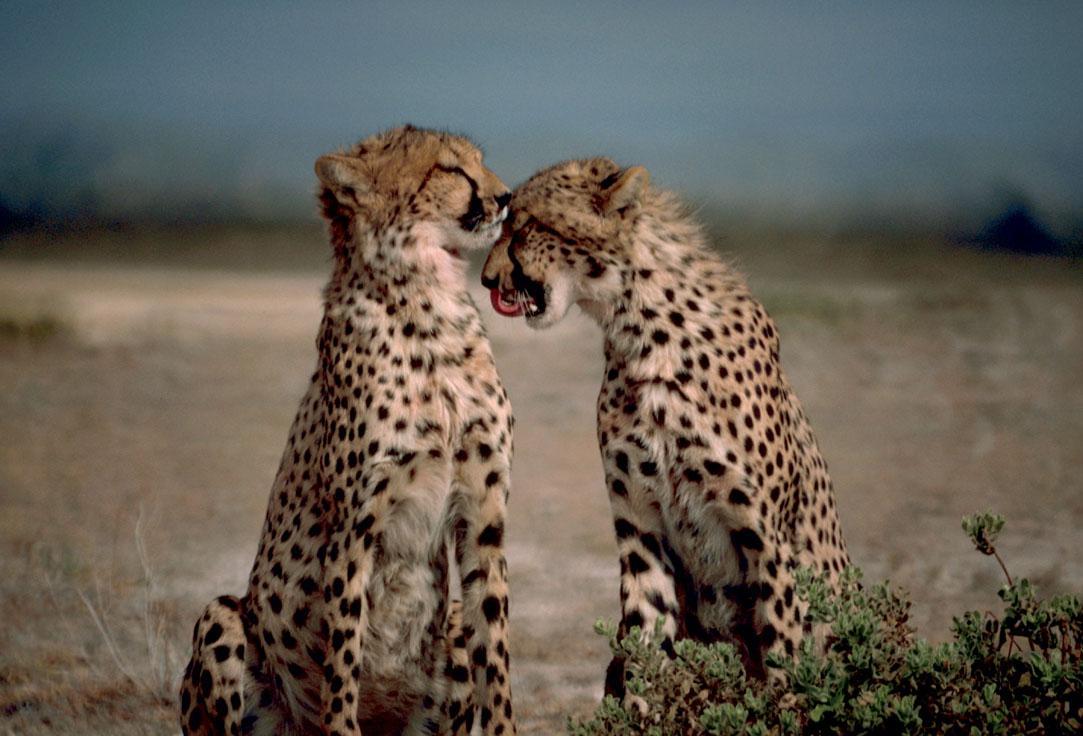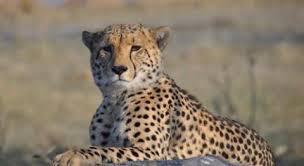The first image is the image on the left, the second image is the image on the right. Considering the images on both sides, is "One image has two Cheetahs with one licking the other." valid? Answer yes or no. Yes. The first image is the image on the left, the second image is the image on the right. Considering the images on both sides, is "2 cheetahs are laying in green grass" valid? Answer yes or no. No. 